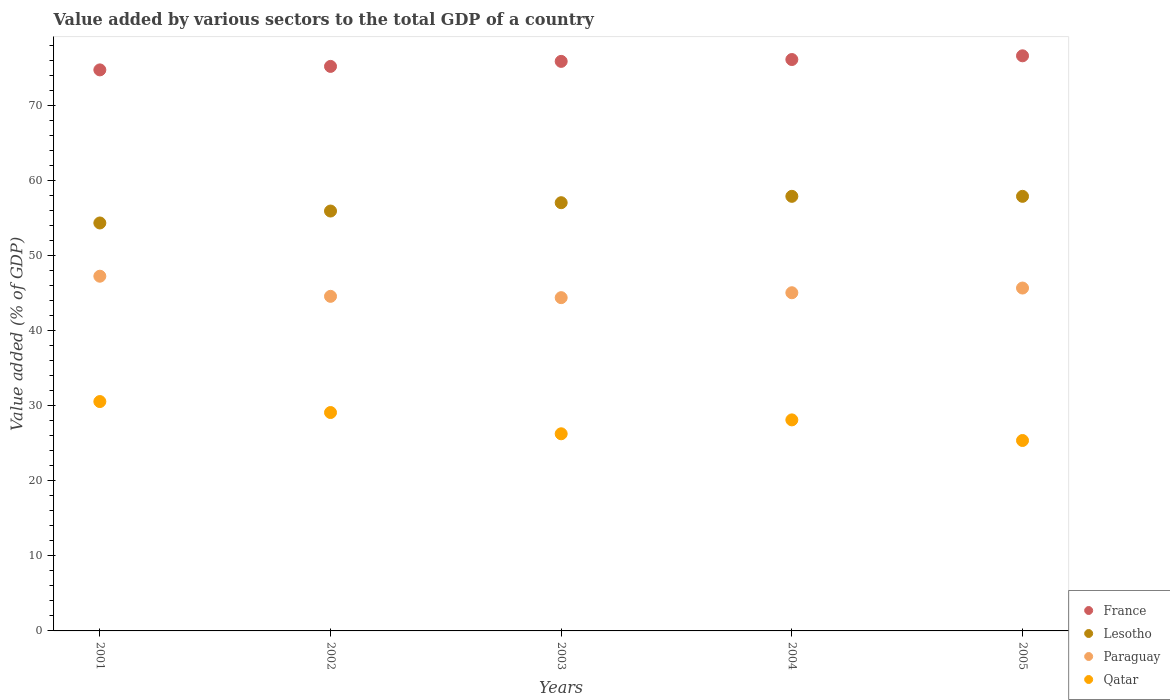What is the value added by various sectors to the total GDP in France in 2002?
Keep it short and to the point. 75.21. Across all years, what is the maximum value added by various sectors to the total GDP in Paraguay?
Provide a succinct answer. 47.26. Across all years, what is the minimum value added by various sectors to the total GDP in Paraguay?
Your answer should be very brief. 44.4. What is the total value added by various sectors to the total GDP in Lesotho in the graph?
Provide a succinct answer. 283.14. What is the difference between the value added by various sectors to the total GDP in France in 2002 and that in 2003?
Your answer should be compact. -0.67. What is the difference between the value added by various sectors to the total GDP in Lesotho in 2002 and the value added by various sectors to the total GDP in Qatar in 2003?
Offer a terse response. 29.68. What is the average value added by various sectors to the total GDP in France per year?
Offer a terse response. 75.72. In the year 2002, what is the difference between the value added by various sectors to the total GDP in France and value added by various sectors to the total GDP in Lesotho?
Provide a succinct answer. 19.27. In how many years, is the value added by various sectors to the total GDP in Paraguay greater than 18 %?
Give a very brief answer. 5. What is the ratio of the value added by various sectors to the total GDP in Lesotho in 2003 to that in 2005?
Your response must be concise. 0.99. Is the value added by various sectors to the total GDP in Paraguay in 2002 less than that in 2003?
Keep it short and to the point. No. What is the difference between the highest and the second highest value added by various sectors to the total GDP in France?
Provide a succinct answer. 0.5. What is the difference between the highest and the lowest value added by various sectors to the total GDP in Lesotho?
Make the answer very short. 3.55. In how many years, is the value added by various sectors to the total GDP in Lesotho greater than the average value added by various sectors to the total GDP in Lesotho taken over all years?
Your answer should be compact. 3. Is the sum of the value added by various sectors to the total GDP in Lesotho in 2003 and 2005 greater than the maximum value added by various sectors to the total GDP in Qatar across all years?
Give a very brief answer. Yes. Is it the case that in every year, the sum of the value added by various sectors to the total GDP in Lesotho and value added by various sectors to the total GDP in France  is greater than the sum of value added by various sectors to the total GDP in Paraguay and value added by various sectors to the total GDP in Qatar?
Provide a succinct answer. Yes. Does the value added by various sectors to the total GDP in Lesotho monotonically increase over the years?
Your response must be concise. No. Is the value added by various sectors to the total GDP in France strictly greater than the value added by various sectors to the total GDP in Qatar over the years?
Your response must be concise. Yes. How many dotlines are there?
Offer a terse response. 4. How many years are there in the graph?
Your answer should be very brief. 5. Does the graph contain any zero values?
Offer a terse response. No. Where does the legend appear in the graph?
Your answer should be compact. Bottom right. What is the title of the graph?
Provide a succinct answer. Value added by various sectors to the total GDP of a country. What is the label or title of the Y-axis?
Provide a short and direct response. Value added (% of GDP). What is the Value added (% of GDP) in France in 2001?
Provide a succinct answer. 74.75. What is the Value added (% of GDP) of Lesotho in 2001?
Provide a succinct answer. 54.35. What is the Value added (% of GDP) of Paraguay in 2001?
Your answer should be compact. 47.26. What is the Value added (% of GDP) in Qatar in 2001?
Give a very brief answer. 30.56. What is the Value added (% of GDP) of France in 2002?
Provide a succinct answer. 75.21. What is the Value added (% of GDP) of Lesotho in 2002?
Your answer should be compact. 55.94. What is the Value added (% of GDP) in Paraguay in 2002?
Your answer should be compact. 44.58. What is the Value added (% of GDP) in Qatar in 2002?
Make the answer very short. 29.1. What is the Value added (% of GDP) in France in 2003?
Provide a succinct answer. 75.88. What is the Value added (% of GDP) of Lesotho in 2003?
Your response must be concise. 57.05. What is the Value added (% of GDP) in Paraguay in 2003?
Provide a short and direct response. 44.4. What is the Value added (% of GDP) in Qatar in 2003?
Provide a short and direct response. 26.26. What is the Value added (% of GDP) in France in 2004?
Keep it short and to the point. 76.13. What is the Value added (% of GDP) of Lesotho in 2004?
Your answer should be very brief. 57.9. What is the Value added (% of GDP) of Paraguay in 2004?
Your response must be concise. 45.06. What is the Value added (% of GDP) in Qatar in 2004?
Your answer should be compact. 28.12. What is the Value added (% of GDP) in France in 2005?
Your answer should be very brief. 76.62. What is the Value added (% of GDP) of Lesotho in 2005?
Your response must be concise. 57.9. What is the Value added (% of GDP) in Paraguay in 2005?
Give a very brief answer. 45.68. What is the Value added (% of GDP) in Qatar in 2005?
Ensure brevity in your answer.  25.37. Across all years, what is the maximum Value added (% of GDP) of France?
Offer a very short reply. 76.62. Across all years, what is the maximum Value added (% of GDP) in Lesotho?
Make the answer very short. 57.9. Across all years, what is the maximum Value added (% of GDP) of Paraguay?
Make the answer very short. 47.26. Across all years, what is the maximum Value added (% of GDP) in Qatar?
Your answer should be compact. 30.56. Across all years, what is the minimum Value added (% of GDP) of France?
Give a very brief answer. 74.75. Across all years, what is the minimum Value added (% of GDP) of Lesotho?
Keep it short and to the point. 54.35. Across all years, what is the minimum Value added (% of GDP) in Paraguay?
Give a very brief answer. 44.4. Across all years, what is the minimum Value added (% of GDP) in Qatar?
Ensure brevity in your answer.  25.37. What is the total Value added (% of GDP) in France in the graph?
Offer a very short reply. 378.58. What is the total Value added (% of GDP) in Lesotho in the graph?
Your answer should be very brief. 283.14. What is the total Value added (% of GDP) in Paraguay in the graph?
Your answer should be compact. 226.97. What is the total Value added (% of GDP) in Qatar in the graph?
Offer a terse response. 139.4. What is the difference between the Value added (% of GDP) of France in 2001 and that in 2002?
Your answer should be very brief. -0.46. What is the difference between the Value added (% of GDP) in Lesotho in 2001 and that in 2002?
Ensure brevity in your answer.  -1.59. What is the difference between the Value added (% of GDP) of Paraguay in 2001 and that in 2002?
Ensure brevity in your answer.  2.68. What is the difference between the Value added (% of GDP) of Qatar in 2001 and that in 2002?
Your answer should be compact. 1.46. What is the difference between the Value added (% of GDP) in France in 2001 and that in 2003?
Provide a succinct answer. -1.13. What is the difference between the Value added (% of GDP) of Lesotho in 2001 and that in 2003?
Your answer should be very brief. -2.7. What is the difference between the Value added (% of GDP) in Paraguay in 2001 and that in 2003?
Make the answer very short. 2.86. What is the difference between the Value added (% of GDP) of Qatar in 2001 and that in 2003?
Your answer should be compact. 4.29. What is the difference between the Value added (% of GDP) in France in 2001 and that in 2004?
Your answer should be very brief. -1.38. What is the difference between the Value added (% of GDP) in Lesotho in 2001 and that in 2004?
Your answer should be very brief. -3.55. What is the difference between the Value added (% of GDP) in Paraguay in 2001 and that in 2004?
Offer a very short reply. 2.2. What is the difference between the Value added (% of GDP) in Qatar in 2001 and that in 2004?
Provide a succinct answer. 2.44. What is the difference between the Value added (% of GDP) of France in 2001 and that in 2005?
Ensure brevity in your answer.  -1.88. What is the difference between the Value added (% of GDP) of Lesotho in 2001 and that in 2005?
Your answer should be compact. -3.55. What is the difference between the Value added (% of GDP) of Paraguay in 2001 and that in 2005?
Provide a short and direct response. 1.58. What is the difference between the Value added (% of GDP) in Qatar in 2001 and that in 2005?
Your answer should be very brief. 5.19. What is the difference between the Value added (% of GDP) in France in 2002 and that in 2003?
Offer a terse response. -0.67. What is the difference between the Value added (% of GDP) of Lesotho in 2002 and that in 2003?
Offer a very short reply. -1.11. What is the difference between the Value added (% of GDP) in Paraguay in 2002 and that in 2003?
Provide a short and direct response. 0.17. What is the difference between the Value added (% of GDP) of Qatar in 2002 and that in 2003?
Make the answer very short. 2.83. What is the difference between the Value added (% of GDP) in France in 2002 and that in 2004?
Offer a very short reply. -0.92. What is the difference between the Value added (% of GDP) in Lesotho in 2002 and that in 2004?
Provide a succinct answer. -1.96. What is the difference between the Value added (% of GDP) in Paraguay in 2002 and that in 2004?
Give a very brief answer. -0.48. What is the difference between the Value added (% of GDP) of Qatar in 2002 and that in 2004?
Make the answer very short. 0.98. What is the difference between the Value added (% of GDP) in France in 2002 and that in 2005?
Your answer should be compact. -1.41. What is the difference between the Value added (% of GDP) in Lesotho in 2002 and that in 2005?
Give a very brief answer. -1.96. What is the difference between the Value added (% of GDP) in Paraguay in 2002 and that in 2005?
Offer a terse response. -1.11. What is the difference between the Value added (% of GDP) in Qatar in 2002 and that in 2005?
Your answer should be very brief. 3.73. What is the difference between the Value added (% of GDP) of France in 2003 and that in 2004?
Offer a terse response. -0.25. What is the difference between the Value added (% of GDP) in Lesotho in 2003 and that in 2004?
Offer a very short reply. -0.85. What is the difference between the Value added (% of GDP) of Paraguay in 2003 and that in 2004?
Keep it short and to the point. -0.65. What is the difference between the Value added (% of GDP) of Qatar in 2003 and that in 2004?
Your response must be concise. -1.85. What is the difference between the Value added (% of GDP) in France in 2003 and that in 2005?
Make the answer very short. -0.74. What is the difference between the Value added (% of GDP) of Lesotho in 2003 and that in 2005?
Provide a succinct answer. -0.85. What is the difference between the Value added (% of GDP) in Paraguay in 2003 and that in 2005?
Provide a succinct answer. -1.28. What is the difference between the Value added (% of GDP) of Qatar in 2003 and that in 2005?
Ensure brevity in your answer.  0.89. What is the difference between the Value added (% of GDP) in France in 2004 and that in 2005?
Your response must be concise. -0.5. What is the difference between the Value added (% of GDP) in Paraguay in 2004 and that in 2005?
Your answer should be very brief. -0.63. What is the difference between the Value added (% of GDP) in Qatar in 2004 and that in 2005?
Offer a terse response. 2.75. What is the difference between the Value added (% of GDP) of France in 2001 and the Value added (% of GDP) of Lesotho in 2002?
Make the answer very short. 18.81. What is the difference between the Value added (% of GDP) of France in 2001 and the Value added (% of GDP) of Paraguay in 2002?
Give a very brief answer. 30.17. What is the difference between the Value added (% of GDP) of France in 2001 and the Value added (% of GDP) of Qatar in 2002?
Provide a succinct answer. 45.65. What is the difference between the Value added (% of GDP) of Lesotho in 2001 and the Value added (% of GDP) of Paraguay in 2002?
Provide a short and direct response. 9.77. What is the difference between the Value added (% of GDP) of Lesotho in 2001 and the Value added (% of GDP) of Qatar in 2002?
Your answer should be very brief. 25.25. What is the difference between the Value added (% of GDP) in Paraguay in 2001 and the Value added (% of GDP) in Qatar in 2002?
Your response must be concise. 18.16. What is the difference between the Value added (% of GDP) of France in 2001 and the Value added (% of GDP) of Lesotho in 2003?
Your answer should be very brief. 17.69. What is the difference between the Value added (% of GDP) in France in 2001 and the Value added (% of GDP) in Paraguay in 2003?
Offer a very short reply. 30.34. What is the difference between the Value added (% of GDP) of France in 2001 and the Value added (% of GDP) of Qatar in 2003?
Provide a succinct answer. 48.48. What is the difference between the Value added (% of GDP) of Lesotho in 2001 and the Value added (% of GDP) of Paraguay in 2003?
Your response must be concise. 9.95. What is the difference between the Value added (% of GDP) of Lesotho in 2001 and the Value added (% of GDP) of Qatar in 2003?
Offer a terse response. 28.09. What is the difference between the Value added (% of GDP) of Paraguay in 2001 and the Value added (% of GDP) of Qatar in 2003?
Ensure brevity in your answer.  20.99. What is the difference between the Value added (% of GDP) in France in 2001 and the Value added (% of GDP) in Lesotho in 2004?
Provide a succinct answer. 16.85. What is the difference between the Value added (% of GDP) in France in 2001 and the Value added (% of GDP) in Paraguay in 2004?
Offer a very short reply. 29.69. What is the difference between the Value added (% of GDP) of France in 2001 and the Value added (% of GDP) of Qatar in 2004?
Make the answer very short. 46.63. What is the difference between the Value added (% of GDP) of Lesotho in 2001 and the Value added (% of GDP) of Paraguay in 2004?
Offer a terse response. 9.3. What is the difference between the Value added (% of GDP) of Lesotho in 2001 and the Value added (% of GDP) of Qatar in 2004?
Offer a terse response. 26.23. What is the difference between the Value added (% of GDP) in Paraguay in 2001 and the Value added (% of GDP) in Qatar in 2004?
Ensure brevity in your answer.  19.14. What is the difference between the Value added (% of GDP) in France in 2001 and the Value added (% of GDP) in Lesotho in 2005?
Ensure brevity in your answer.  16.85. What is the difference between the Value added (% of GDP) of France in 2001 and the Value added (% of GDP) of Paraguay in 2005?
Provide a short and direct response. 29.06. What is the difference between the Value added (% of GDP) in France in 2001 and the Value added (% of GDP) in Qatar in 2005?
Keep it short and to the point. 49.38. What is the difference between the Value added (% of GDP) in Lesotho in 2001 and the Value added (% of GDP) in Paraguay in 2005?
Your response must be concise. 8.67. What is the difference between the Value added (% of GDP) in Lesotho in 2001 and the Value added (% of GDP) in Qatar in 2005?
Ensure brevity in your answer.  28.98. What is the difference between the Value added (% of GDP) of Paraguay in 2001 and the Value added (% of GDP) of Qatar in 2005?
Offer a terse response. 21.89. What is the difference between the Value added (% of GDP) in France in 2002 and the Value added (% of GDP) in Lesotho in 2003?
Keep it short and to the point. 18.16. What is the difference between the Value added (% of GDP) in France in 2002 and the Value added (% of GDP) in Paraguay in 2003?
Your answer should be very brief. 30.81. What is the difference between the Value added (% of GDP) of France in 2002 and the Value added (% of GDP) of Qatar in 2003?
Keep it short and to the point. 48.95. What is the difference between the Value added (% of GDP) of Lesotho in 2002 and the Value added (% of GDP) of Paraguay in 2003?
Offer a very short reply. 11.54. What is the difference between the Value added (% of GDP) in Lesotho in 2002 and the Value added (% of GDP) in Qatar in 2003?
Give a very brief answer. 29.68. What is the difference between the Value added (% of GDP) in Paraguay in 2002 and the Value added (% of GDP) in Qatar in 2003?
Provide a short and direct response. 18.31. What is the difference between the Value added (% of GDP) in France in 2002 and the Value added (% of GDP) in Lesotho in 2004?
Make the answer very short. 17.31. What is the difference between the Value added (% of GDP) of France in 2002 and the Value added (% of GDP) of Paraguay in 2004?
Make the answer very short. 30.16. What is the difference between the Value added (% of GDP) in France in 2002 and the Value added (% of GDP) in Qatar in 2004?
Give a very brief answer. 47.09. What is the difference between the Value added (% of GDP) in Lesotho in 2002 and the Value added (% of GDP) in Paraguay in 2004?
Your answer should be very brief. 10.88. What is the difference between the Value added (% of GDP) in Lesotho in 2002 and the Value added (% of GDP) in Qatar in 2004?
Give a very brief answer. 27.82. What is the difference between the Value added (% of GDP) of Paraguay in 2002 and the Value added (% of GDP) of Qatar in 2004?
Ensure brevity in your answer.  16.46. What is the difference between the Value added (% of GDP) in France in 2002 and the Value added (% of GDP) in Lesotho in 2005?
Provide a short and direct response. 17.31. What is the difference between the Value added (% of GDP) in France in 2002 and the Value added (% of GDP) in Paraguay in 2005?
Your response must be concise. 29.53. What is the difference between the Value added (% of GDP) of France in 2002 and the Value added (% of GDP) of Qatar in 2005?
Make the answer very short. 49.84. What is the difference between the Value added (% of GDP) of Lesotho in 2002 and the Value added (% of GDP) of Paraguay in 2005?
Your answer should be compact. 10.26. What is the difference between the Value added (% of GDP) in Lesotho in 2002 and the Value added (% of GDP) in Qatar in 2005?
Your response must be concise. 30.57. What is the difference between the Value added (% of GDP) in Paraguay in 2002 and the Value added (% of GDP) in Qatar in 2005?
Your answer should be compact. 19.21. What is the difference between the Value added (% of GDP) in France in 2003 and the Value added (% of GDP) in Lesotho in 2004?
Your response must be concise. 17.98. What is the difference between the Value added (% of GDP) of France in 2003 and the Value added (% of GDP) of Paraguay in 2004?
Provide a succinct answer. 30.82. What is the difference between the Value added (% of GDP) of France in 2003 and the Value added (% of GDP) of Qatar in 2004?
Your answer should be compact. 47.76. What is the difference between the Value added (% of GDP) in Lesotho in 2003 and the Value added (% of GDP) in Paraguay in 2004?
Your response must be concise. 12. What is the difference between the Value added (% of GDP) in Lesotho in 2003 and the Value added (% of GDP) in Qatar in 2004?
Provide a short and direct response. 28.94. What is the difference between the Value added (% of GDP) in Paraguay in 2003 and the Value added (% of GDP) in Qatar in 2004?
Ensure brevity in your answer.  16.29. What is the difference between the Value added (% of GDP) of France in 2003 and the Value added (% of GDP) of Lesotho in 2005?
Make the answer very short. 17.98. What is the difference between the Value added (% of GDP) in France in 2003 and the Value added (% of GDP) in Paraguay in 2005?
Offer a very short reply. 30.2. What is the difference between the Value added (% of GDP) in France in 2003 and the Value added (% of GDP) in Qatar in 2005?
Your answer should be very brief. 50.51. What is the difference between the Value added (% of GDP) of Lesotho in 2003 and the Value added (% of GDP) of Paraguay in 2005?
Keep it short and to the point. 11.37. What is the difference between the Value added (% of GDP) of Lesotho in 2003 and the Value added (% of GDP) of Qatar in 2005?
Offer a terse response. 31.68. What is the difference between the Value added (% of GDP) in Paraguay in 2003 and the Value added (% of GDP) in Qatar in 2005?
Your answer should be compact. 19.03. What is the difference between the Value added (% of GDP) in France in 2004 and the Value added (% of GDP) in Lesotho in 2005?
Provide a short and direct response. 18.23. What is the difference between the Value added (% of GDP) of France in 2004 and the Value added (% of GDP) of Paraguay in 2005?
Offer a very short reply. 30.44. What is the difference between the Value added (% of GDP) in France in 2004 and the Value added (% of GDP) in Qatar in 2005?
Ensure brevity in your answer.  50.76. What is the difference between the Value added (% of GDP) of Lesotho in 2004 and the Value added (% of GDP) of Paraguay in 2005?
Provide a short and direct response. 12.22. What is the difference between the Value added (% of GDP) in Lesotho in 2004 and the Value added (% of GDP) in Qatar in 2005?
Make the answer very short. 32.53. What is the difference between the Value added (% of GDP) of Paraguay in 2004 and the Value added (% of GDP) of Qatar in 2005?
Provide a succinct answer. 19.69. What is the average Value added (% of GDP) in France per year?
Your response must be concise. 75.72. What is the average Value added (% of GDP) of Lesotho per year?
Your response must be concise. 56.63. What is the average Value added (% of GDP) in Paraguay per year?
Your answer should be compact. 45.39. What is the average Value added (% of GDP) of Qatar per year?
Your answer should be compact. 27.88. In the year 2001, what is the difference between the Value added (% of GDP) of France and Value added (% of GDP) of Lesotho?
Provide a succinct answer. 20.4. In the year 2001, what is the difference between the Value added (% of GDP) of France and Value added (% of GDP) of Paraguay?
Keep it short and to the point. 27.49. In the year 2001, what is the difference between the Value added (% of GDP) of France and Value added (% of GDP) of Qatar?
Provide a succinct answer. 44.19. In the year 2001, what is the difference between the Value added (% of GDP) in Lesotho and Value added (% of GDP) in Paraguay?
Provide a succinct answer. 7.09. In the year 2001, what is the difference between the Value added (% of GDP) in Lesotho and Value added (% of GDP) in Qatar?
Make the answer very short. 23.79. In the year 2001, what is the difference between the Value added (% of GDP) in Paraguay and Value added (% of GDP) in Qatar?
Give a very brief answer. 16.7. In the year 2002, what is the difference between the Value added (% of GDP) of France and Value added (% of GDP) of Lesotho?
Offer a very short reply. 19.27. In the year 2002, what is the difference between the Value added (% of GDP) of France and Value added (% of GDP) of Paraguay?
Offer a terse response. 30.63. In the year 2002, what is the difference between the Value added (% of GDP) in France and Value added (% of GDP) in Qatar?
Keep it short and to the point. 46.11. In the year 2002, what is the difference between the Value added (% of GDP) in Lesotho and Value added (% of GDP) in Paraguay?
Ensure brevity in your answer.  11.36. In the year 2002, what is the difference between the Value added (% of GDP) in Lesotho and Value added (% of GDP) in Qatar?
Provide a short and direct response. 26.84. In the year 2002, what is the difference between the Value added (% of GDP) of Paraguay and Value added (% of GDP) of Qatar?
Your answer should be compact. 15.48. In the year 2003, what is the difference between the Value added (% of GDP) in France and Value added (% of GDP) in Lesotho?
Keep it short and to the point. 18.83. In the year 2003, what is the difference between the Value added (% of GDP) in France and Value added (% of GDP) in Paraguay?
Your answer should be compact. 31.48. In the year 2003, what is the difference between the Value added (% of GDP) of France and Value added (% of GDP) of Qatar?
Your answer should be compact. 49.61. In the year 2003, what is the difference between the Value added (% of GDP) of Lesotho and Value added (% of GDP) of Paraguay?
Give a very brief answer. 12.65. In the year 2003, what is the difference between the Value added (% of GDP) in Lesotho and Value added (% of GDP) in Qatar?
Your answer should be very brief. 30.79. In the year 2003, what is the difference between the Value added (% of GDP) of Paraguay and Value added (% of GDP) of Qatar?
Keep it short and to the point. 18.14. In the year 2004, what is the difference between the Value added (% of GDP) in France and Value added (% of GDP) in Lesotho?
Provide a succinct answer. 18.23. In the year 2004, what is the difference between the Value added (% of GDP) in France and Value added (% of GDP) in Paraguay?
Give a very brief answer. 31.07. In the year 2004, what is the difference between the Value added (% of GDP) in France and Value added (% of GDP) in Qatar?
Your answer should be compact. 48.01. In the year 2004, what is the difference between the Value added (% of GDP) of Lesotho and Value added (% of GDP) of Paraguay?
Make the answer very short. 12.84. In the year 2004, what is the difference between the Value added (% of GDP) of Lesotho and Value added (% of GDP) of Qatar?
Ensure brevity in your answer.  29.78. In the year 2004, what is the difference between the Value added (% of GDP) of Paraguay and Value added (% of GDP) of Qatar?
Provide a short and direct response. 16.94. In the year 2005, what is the difference between the Value added (% of GDP) of France and Value added (% of GDP) of Lesotho?
Offer a terse response. 18.72. In the year 2005, what is the difference between the Value added (% of GDP) in France and Value added (% of GDP) in Paraguay?
Make the answer very short. 30.94. In the year 2005, what is the difference between the Value added (% of GDP) of France and Value added (% of GDP) of Qatar?
Your answer should be compact. 51.25. In the year 2005, what is the difference between the Value added (% of GDP) in Lesotho and Value added (% of GDP) in Paraguay?
Provide a short and direct response. 12.22. In the year 2005, what is the difference between the Value added (% of GDP) in Lesotho and Value added (% of GDP) in Qatar?
Offer a terse response. 32.53. In the year 2005, what is the difference between the Value added (% of GDP) of Paraguay and Value added (% of GDP) of Qatar?
Give a very brief answer. 20.31. What is the ratio of the Value added (% of GDP) of Lesotho in 2001 to that in 2002?
Your answer should be very brief. 0.97. What is the ratio of the Value added (% of GDP) of Paraguay in 2001 to that in 2002?
Provide a succinct answer. 1.06. What is the ratio of the Value added (% of GDP) in Qatar in 2001 to that in 2002?
Make the answer very short. 1.05. What is the ratio of the Value added (% of GDP) in France in 2001 to that in 2003?
Offer a very short reply. 0.99. What is the ratio of the Value added (% of GDP) of Lesotho in 2001 to that in 2003?
Keep it short and to the point. 0.95. What is the ratio of the Value added (% of GDP) of Paraguay in 2001 to that in 2003?
Give a very brief answer. 1.06. What is the ratio of the Value added (% of GDP) in Qatar in 2001 to that in 2003?
Your answer should be very brief. 1.16. What is the ratio of the Value added (% of GDP) of France in 2001 to that in 2004?
Make the answer very short. 0.98. What is the ratio of the Value added (% of GDP) of Lesotho in 2001 to that in 2004?
Provide a succinct answer. 0.94. What is the ratio of the Value added (% of GDP) of Paraguay in 2001 to that in 2004?
Offer a terse response. 1.05. What is the ratio of the Value added (% of GDP) of Qatar in 2001 to that in 2004?
Your answer should be compact. 1.09. What is the ratio of the Value added (% of GDP) in France in 2001 to that in 2005?
Your response must be concise. 0.98. What is the ratio of the Value added (% of GDP) of Lesotho in 2001 to that in 2005?
Provide a short and direct response. 0.94. What is the ratio of the Value added (% of GDP) in Paraguay in 2001 to that in 2005?
Give a very brief answer. 1.03. What is the ratio of the Value added (% of GDP) in Qatar in 2001 to that in 2005?
Give a very brief answer. 1.2. What is the ratio of the Value added (% of GDP) in Lesotho in 2002 to that in 2003?
Ensure brevity in your answer.  0.98. What is the ratio of the Value added (% of GDP) of Qatar in 2002 to that in 2003?
Offer a very short reply. 1.11. What is the ratio of the Value added (% of GDP) in Lesotho in 2002 to that in 2004?
Ensure brevity in your answer.  0.97. What is the ratio of the Value added (% of GDP) of Qatar in 2002 to that in 2004?
Your answer should be very brief. 1.03. What is the ratio of the Value added (% of GDP) in France in 2002 to that in 2005?
Give a very brief answer. 0.98. What is the ratio of the Value added (% of GDP) in Lesotho in 2002 to that in 2005?
Give a very brief answer. 0.97. What is the ratio of the Value added (% of GDP) in Paraguay in 2002 to that in 2005?
Ensure brevity in your answer.  0.98. What is the ratio of the Value added (% of GDP) of Qatar in 2002 to that in 2005?
Make the answer very short. 1.15. What is the ratio of the Value added (% of GDP) of France in 2003 to that in 2004?
Your answer should be very brief. 1. What is the ratio of the Value added (% of GDP) in Lesotho in 2003 to that in 2004?
Ensure brevity in your answer.  0.99. What is the ratio of the Value added (% of GDP) of Paraguay in 2003 to that in 2004?
Give a very brief answer. 0.99. What is the ratio of the Value added (% of GDP) of Qatar in 2003 to that in 2004?
Ensure brevity in your answer.  0.93. What is the ratio of the Value added (% of GDP) in France in 2003 to that in 2005?
Ensure brevity in your answer.  0.99. What is the ratio of the Value added (% of GDP) of Lesotho in 2003 to that in 2005?
Offer a very short reply. 0.99. What is the ratio of the Value added (% of GDP) in Paraguay in 2003 to that in 2005?
Your answer should be compact. 0.97. What is the ratio of the Value added (% of GDP) in Qatar in 2003 to that in 2005?
Your answer should be compact. 1.04. What is the ratio of the Value added (% of GDP) of France in 2004 to that in 2005?
Provide a short and direct response. 0.99. What is the ratio of the Value added (% of GDP) in Paraguay in 2004 to that in 2005?
Offer a terse response. 0.99. What is the ratio of the Value added (% of GDP) of Qatar in 2004 to that in 2005?
Offer a terse response. 1.11. What is the difference between the highest and the second highest Value added (% of GDP) of France?
Offer a terse response. 0.5. What is the difference between the highest and the second highest Value added (% of GDP) of Lesotho?
Make the answer very short. 0. What is the difference between the highest and the second highest Value added (% of GDP) of Paraguay?
Provide a succinct answer. 1.58. What is the difference between the highest and the second highest Value added (% of GDP) in Qatar?
Ensure brevity in your answer.  1.46. What is the difference between the highest and the lowest Value added (% of GDP) in France?
Ensure brevity in your answer.  1.88. What is the difference between the highest and the lowest Value added (% of GDP) in Lesotho?
Your answer should be very brief. 3.55. What is the difference between the highest and the lowest Value added (% of GDP) of Paraguay?
Offer a very short reply. 2.86. What is the difference between the highest and the lowest Value added (% of GDP) of Qatar?
Ensure brevity in your answer.  5.19. 